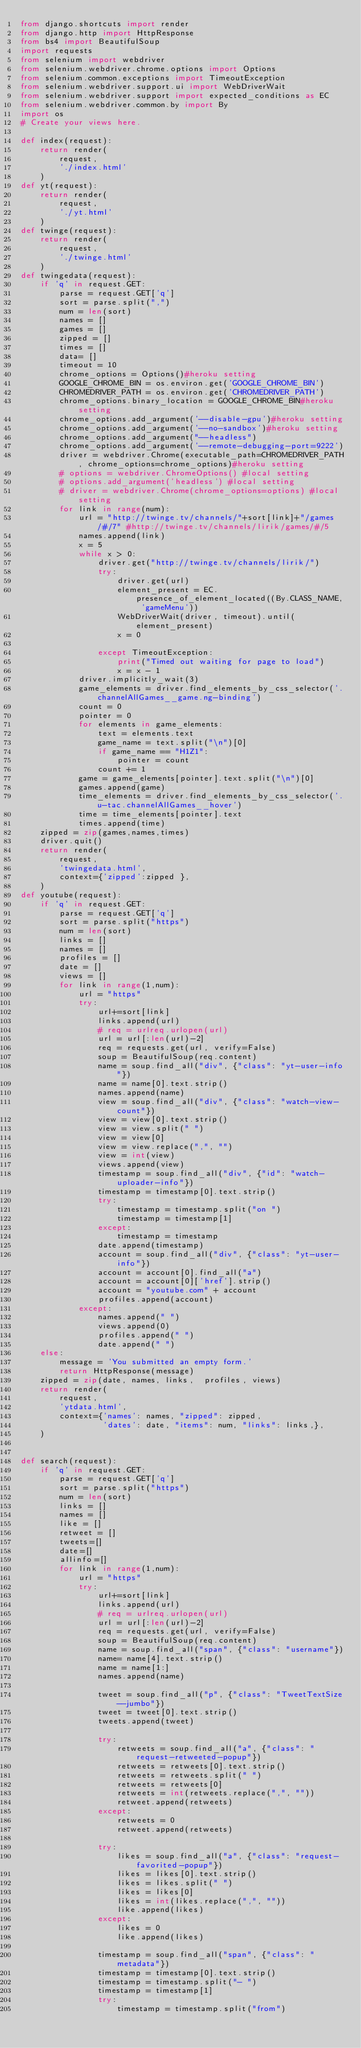Convert code to text. <code><loc_0><loc_0><loc_500><loc_500><_Python_>from django.shortcuts import render
from django.http import HttpResponse
from bs4 import BeautifulSoup
import requests
from selenium import webdriver
from selenium.webdriver.chrome.options import Options
from selenium.common.exceptions import TimeoutException
from selenium.webdriver.support.ui import WebDriverWait
from selenium.webdriver.support import expected_conditions as EC
from selenium.webdriver.common.by import By
import os
# Create your views here.

def index(request):
    return render(
        request,
        './index.html'
    )
def yt(request):
    return render(
        request,
        './yt.html'
    )
def twinge(request):
    return render(
        request,
        './twinge.html'
    )
def twingedata(request):
    if 'q' in request.GET:
        parse = request.GET['q']
        sort = parse.split(",")
        num = len(sort)
        names = []
        games = []
        zipped = []
        times = []
        data= []
        timeout = 10
        chrome_options = Options()#heroku setting
        GOOGLE_CHROME_BIN = os.environ.get('GOOGLE_CHROME_BIN')
        CHROMEDRIVER_PATH = os.environ.get('CHROMEDRIVER_PATH')
        chrome_options.binary_location = GOOGLE_CHROME_BIN#heroku setting
        chrome_options.add_argument('--disable-gpu')#heroku setting
        chrome_options.add_argument('--no-sandbox')#heroku setting
        chrome_options.add_argument("--headless")
        chrome_options.add_argument('--remote-debugging-port=9222')
        driver = webdriver.Chrome(executable_path=CHROMEDRIVER_PATH, chrome_options=chrome_options)#heroku setting
        # options = webdriver.ChromeOptions() #local setting
        # options.add_argument('headless') #local setting
        # driver = webdriver.Chrome(chrome_options=options) #local setting
        for link in range(num):
            url = "http://twinge.tv/channels/"+sort[link]+"/games/#/7" #http://twinge.tv/channels/lirik/games/#/5
            names.append(link)
            x = 5
            while x > 0:
                driver.get("http://twinge.tv/channels/lirik/")
                try:
                    driver.get(url)
                    element_present = EC.presence_of_element_located((By.CLASS_NAME, 'gameMenu'))
                    WebDriverWait(driver, timeout).until(element_present)
                    x = 0

                except TimeoutException:
                    print("Timed out waiting for page to load")
                    x = x - 1
            driver.implicitly_wait(3)
            game_elements = driver.find_elements_by_css_selector('.channelAllGames__game.ng-binding')
            count = 0
            pointer = 0
            for elements in game_elements:
                text = elements.text
                game_name = text.split("\n")[0]
                if game_name == "H1Z1":
                    pointer = count
                count += 1
            game = game_elements[pointer].text.split("\n")[0]
            games.append(game)
            time_elements = driver.find_elements_by_css_selector('.u-tac.channelAllGames__hover')
            time = time_elements[pointer].text
            times.append(time)
    zipped = zip(games,names,times)
    driver.quit()
    return render(
        request,
        'twingedata.html',
        context={'zipped':zipped },
    )
def youtube(request):
    if 'q' in request.GET:
        parse = request.GET['q']
        sort = parse.split("https")
        num = len(sort)
        links = []
        names = []
        profiles = []
        date = []
        views = []
        for link in range(1,num):
            url = "https"
            try:
                url+=sort[link]
                links.append(url)
                # req = urlreq.urlopen(url)
                url = url[:len(url)-2]
                req = requests.get(url, verify=False)
                soup = BeautifulSoup(req.content)
                name = soup.find_all("div", {"class": "yt-user-info"})
                name = name[0].text.strip()
                names.append(name)
                view = soup.find_all("div", {"class": "watch-view-count"})
                view = view[0].text.strip()
                view = view.split(" ")
                view = view[0]
                view = view.replace(",", "")
                view = int(view)
                views.append(view)
                timestamp = soup.find_all("div", {"id": "watch-uploader-info"})
                timestamp = timestamp[0].text.strip()
                try:
                    timestamp = timestamp.split("on ")
                    timestamp = timestamp[1]
                except:
                    timestamp = timestamp
                date.append(timestamp)
                account = soup.find_all("div", {"class": "yt-user-info"})
                account = account[0].find_all("a")
                account = account[0]['href'].strip()
                account = "youtube.com" + account
                profiles.append(account)
            except:
                names.append(" ")
                views.append(0)
                profiles.append(" ")
                date.append(" ")
    else:
        message = 'You submitted an empty form.'
        return HttpResponse(message)
    zipped = zip(date, names, links,  profiles, views)
    return render(
        request,
        'ytdata.html',
        context={'names': names, "zipped": zipped,
                 'dates': date, "items": num, "links": links,},
    )


def search(request):
    if 'q' in request.GET:
        parse = request.GET['q']
        sort = parse.split("https")
        num = len(sort)
        links = []
        names = []
        like = []
        retweet = []
        tweets=[]
        date=[]
        allinfo=[]
        for link in range(1,num):
            url = "https"
            try:
                url+=sort[link]
                links.append(url)
                # req = urlreq.urlopen(url)
                url = url[:len(url)-2]
                req = requests.get(url, verify=False)
                soup = BeautifulSoup(req.content)
                name = soup.find_all("span", {"class": "username"})
                name= name[4].text.strip()
                name = name[1:]
                names.append(name)

                tweet = soup.find_all("p", {"class": "TweetTextSize--jumbo"})
                tweet = tweet[0].text.strip()
                tweets.append(tweet)

                try:
                    retweets = soup.find_all("a", {"class": "request-retweeted-popup"})
                    retweets = retweets[0].text.strip()
                    retweets = retweets.split(" ")
                    retweets = retweets[0]
                    retweets = int(retweets.replace(",", ""))
                    retweet.append(retweets)
                except:
                    retweets = 0
                    retweet.append(retweets)

                try:
                    likes = soup.find_all("a", {"class": "request-favorited-popup"})
                    likes = likes[0].text.strip()
                    likes = likes.split(" ")
                    likes = likes[0]
                    likes = int(likes.replace(",", ""))
                    like.append(likes)
                except:
                    likes = 0
                    like.append(likes)

                timestamp = soup.find_all("span", {"class": "metadata"})
                timestamp = timestamp[0].text.strip()
                timestamp = timestamp.split("- ")
                timestamp = timestamp[1]
                try:
                    timestamp = timestamp.split("from")</code> 